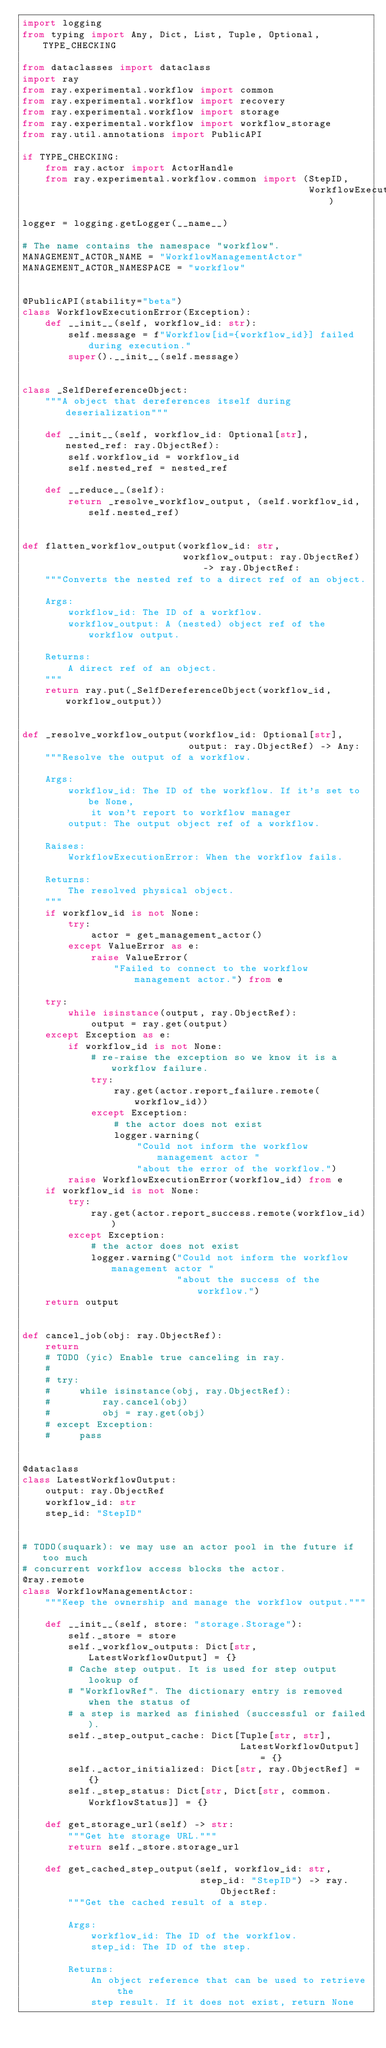<code> <loc_0><loc_0><loc_500><loc_500><_Python_>import logging
from typing import Any, Dict, List, Tuple, Optional, TYPE_CHECKING

from dataclasses import dataclass
import ray
from ray.experimental.workflow import common
from ray.experimental.workflow import recovery
from ray.experimental.workflow import storage
from ray.experimental.workflow import workflow_storage
from ray.util.annotations import PublicAPI

if TYPE_CHECKING:
    from ray.actor import ActorHandle
    from ray.experimental.workflow.common import (StepID,
                                                  WorkflowExecutionResult)

logger = logging.getLogger(__name__)

# The name contains the namespace "workflow".
MANAGEMENT_ACTOR_NAME = "WorkflowManagementActor"
MANAGEMENT_ACTOR_NAMESPACE = "workflow"


@PublicAPI(stability="beta")
class WorkflowExecutionError(Exception):
    def __init__(self, workflow_id: str):
        self.message = f"Workflow[id={workflow_id}] failed during execution."
        super().__init__(self.message)


class _SelfDereferenceObject:
    """A object that dereferences itself during deserialization"""

    def __init__(self, workflow_id: Optional[str], nested_ref: ray.ObjectRef):
        self.workflow_id = workflow_id
        self.nested_ref = nested_ref

    def __reduce__(self):
        return _resolve_workflow_output, (self.workflow_id, self.nested_ref)


def flatten_workflow_output(workflow_id: str,
                            workflow_output: ray.ObjectRef) -> ray.ObjectRef:
    """Converts the nested ref to a direct ref of an object.

    Args:
        workflow_id: The ID of a workflow.
        workflow_output: A (nested) object ref of the workflow output.

    Returns:
        A direct ref of an object.
    """
    return ray.put(_SelfDereferenceObject(workflow_id, workflow_output))


def _resolve_workflow_output(workflow_id: Optional[str],
                             output: ray.ObjectRef) -> Any:
    """Resolve the output of a workflow.

    Args:
        workflow_id: The ID of the workflow. If it's set to be None,
            it won't report to workflow manager
        output: The output object ref of a workflow.

    Raises:
        WorkflowExecutionError: When the workflow fails.

    Returns:
        The resolved physical object.
    """
    if workflow_id is not None:
        try:
            actor = get_management_actor()
        except ValueError as e:
            raise ValueError(
                "Failed to connect to the workflow management actor.") from e

    try:
        while isinstance(output, ray.ObjectRef):
            output = ray.get(output)
    except Exception as e:
        if workflow_id is not None:
            # re-raise the exception so we know it is a workflow failure.
            try:
                ray.get(actor.report_failure.remote(workflow_id))
            except Exception:
                # the actor does not exist
                logger.warning(
                    "Could not inform the workflow management actor "
                    "about the error of the workflow.")
        raise WorkflowExecutionError(workflow_id) from e
    if workflow_id is not None:
        try:
            ray.get(actor.report_success.remote(workflow_id))
        except Exception:
            # the actor does not exist
            logger.warning("Could not inform the workflow management actor "
                           "about the success of the workflow.")
    return output


def cancel_job(obj: ray.ObjectRef):
    return
    # TODO (yic) Enable true canceling in ray.
    #
    # try:
    #     while isinstance(obj, ray.ObjectRef):
    #         ray.cancel(obj)
    #         obj = ray.get(obj)
    # except Exception:
    #     pass


@dataclass
class LatestWorkflowOutput:
    output: ray.ObjectRef
    workflow_id: str
    step_id: "StepID"


# TODO(suquark): we may use an actor pool in the future if too much
# concurrent workflow access blocks the actor.
@ray.remote
class WorkflowManagementActor:
    """Keep the ownership and manage the workflow output."""

    def __init__(self, store: "storage.Storage"):
        self._store = store
        self._workflow_outputs: Dict[str, LatestWorkflowOutput] = {}
        # Cache step output. It is used for step output lookup of
        # "WorkflowRef". The dictionary entry is removed when the status of
        # a step is marked as finished (successful or failed).
        self._step_output_cache: Dict[Tuple[str, str],
                                      LatestWorkflowOutput] = {}
        self._actor_initialized: Dict[str, ray.ObjectRef] = {}
        self._step_status: Dict[str, Dict[str, common.WorkflowStatus]] = {}

    def get_storage_url(self) -> str:
        """Get hte storage URL."""
        return self._store.storage_url

    def get_cached_step_output(self, workflow_id: str,
                               step_id: "StepID") -> ray.ObjectRef:
        """Get the cached result of a step.

        Args:
            workflow_id: The ID of the workflow.
            step_id: The ID of the step.

        Returns:
            An object reference that can be used to retrieve the
            step result. If it does not exist, return None</code> 